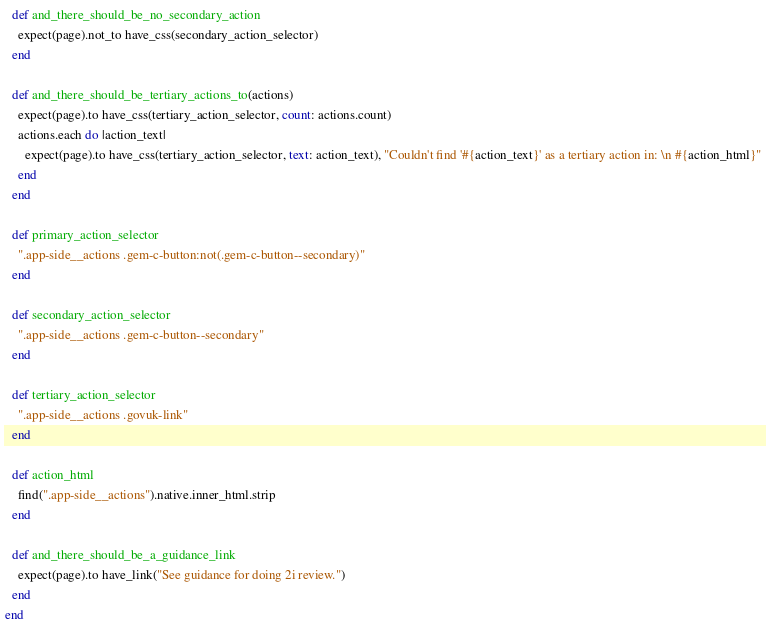<code> <loc_0><loc_0><loc_500><loc_500><_Ruby_>  def and_there_should_be_no_secondary_action
    expect(page).not_to have_css(secondary_action_selector)
  end

  def and_there_should_be_tertiary_actions_to(actions)
    expect(page).to have_css(tertiary_action_selector, count: actions.count)
    actions.each do |action_text|
      expect(page).to have_css(tertiary_action_selector, text: action_text), "Couldn't find '#{action_text}' as a tertiary action in: \n #{action_html}"
    end
  end

  def primary_action_selector
    ".app-side__actions .gem-c-button:not(.gem-c-button--secondary)"
  end

  def secondary_action_selector
    ".app-side__actions .gem-c-button--secondary"
  end

  def tertiary_action_selector
    ".app-side__actions .govuk-link"
  end

  def action_html
    find(".app-side__actions").native.inner_html.strip
  end

  def and_there_should_be_a_guidance_link
    expect(page).to have_link("See guidance for doing 2i review.")
  end
end
</code> 